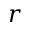Convert formula to latex. <formula><loc_0><loc_0><loc_500><loc_500>r</formula> 